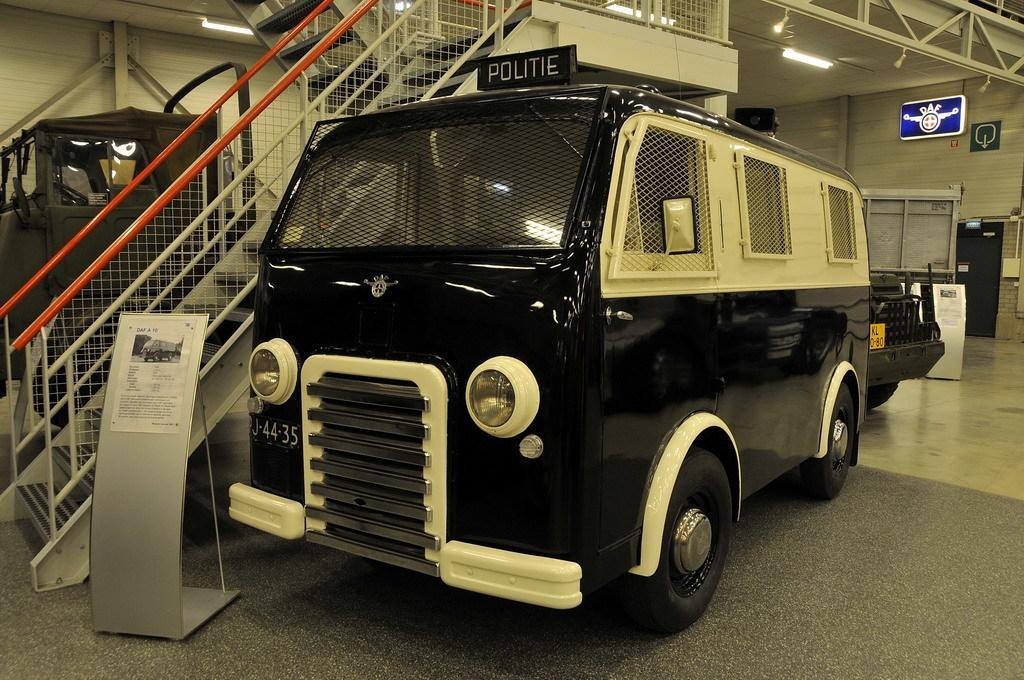Please provide a concise description of this image. In this image, at the middle there is a black color van, on that van there is POLITIE is written, at the left side there are some stairs, at the right side there is a black color car and there is a blue color sign board at top. 